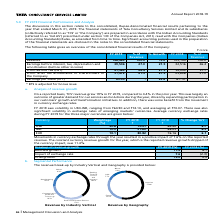According to Tata Consultancy Services's financial document, Which accounting standards are the company's financial statements based on? Indian Accounting Standards. The document states: "the Company’) are prepared in accordance with the Indian Accounting Standards (referred to as ‘Ind AS’) prescribed under section 133 of the Companies ..." Also, What is the percentage growth in revenue from FY 2018 to FY 2019? According to the financial document, 19.0 (percentage). The relevant text states: "Revenue 146,463 100.0 19.0 123,104 100.0 Earnings before interest, tax, depreciation and amortization (before other income) 39..." Also, What is the Earnings per share in FY 2019? According to the financial document, 83.05. The relevant text states: "Earnings per share (in ` ) 83.05 - 23.8 67.10* -..." Also, can you calculate: What is the change in earnings per share between 2018 and 2019? Based on the calculation: 83.05-67.10, the result is 15.95. This is based on the information: "Earnings per share (in ` ) 83.05 - 23.8 67.10* - Earnings per share (in ` ) 83.05 - 23.8 67.10* -..." The key data points involved are: 67.10, 83.05. Also, can you calculate: What is the change in revenue between 2018 and 2019? Based on the calculation: 146,463-123,104, the result is 23359. This is based on the information: "Revenue 146,463 100.0 19.0 123,104 100.0 Earnings before interest, tax, depreciation and amortization (before other income) 39,506 27. Revenue 146,463 100.0 19.0 123,104 100.0 Earnings before interest..." The key data points involved are: 123,104, 146,463. Also, can you calculate: What is the average earnings per share for 2018 and 2019? To answer this question, I need to perform calculations using the financial data. The calculation is: (83.05+ 67.10)/2, which equals 75.07. This is based on the information: "Earnings per share (in ` ) 83.05 - 23.8 67.10* - Earnings per share (in ` ) 83.05 - 23.8 67.10* -..." The key data points involved are: 67.10, 83.05. 